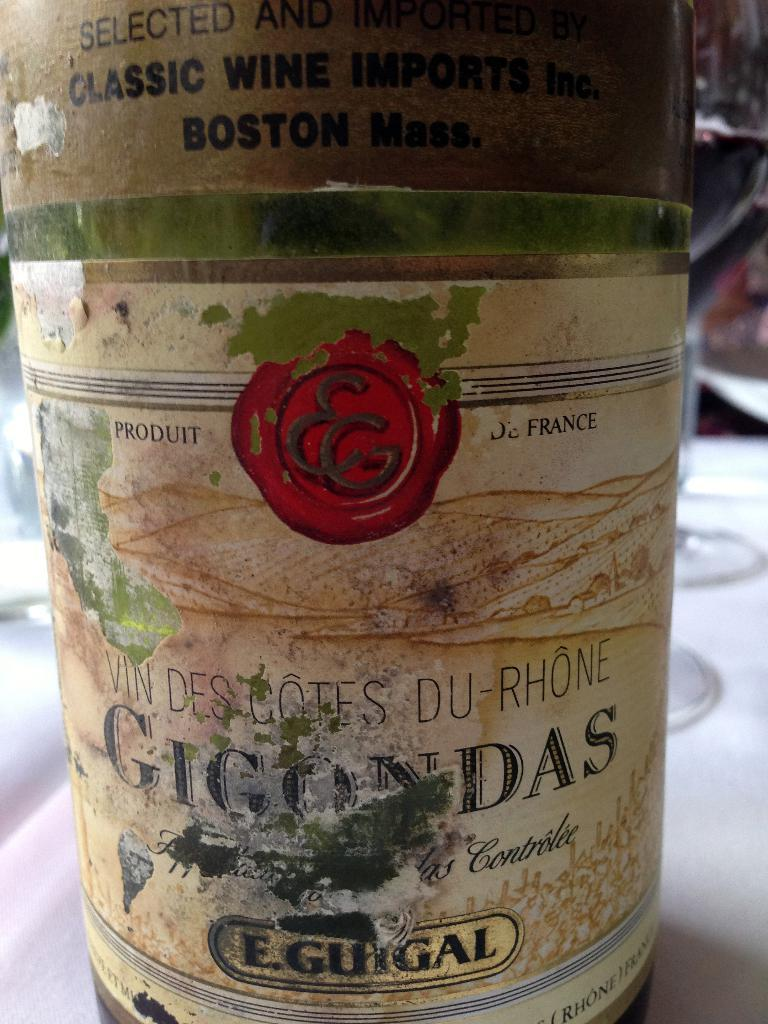<image>
Create a compact narrative representing the image presented. A bottle has a worn label that is marked E. Guigal towards the bottom. 